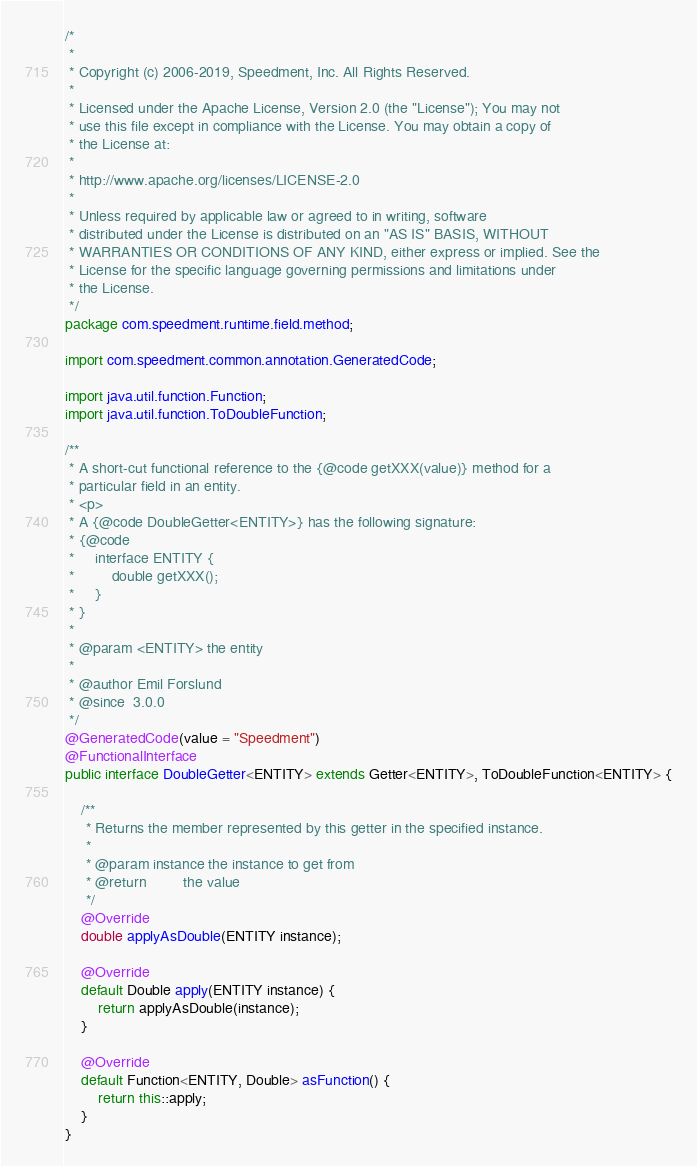<code> <loc_0><loc_0><loc_500><loc_500><_Java_>/*
 *
 * Copyright (c) 2006-2019, Speedment, Inc. All Rights Reserved.
 *
 * Licensed under the Apache License, Version 2.0 (the "License"); You may not
 * use this file except in compliance with the License. You may obtain a copy of
 * the License at:
 *
 * http://www.apache.org/licenses/LICENSE-2.0
 *
 * Unless required by applicable law or agreed to in writing, software
 * distributed under the License is distributed on an "AS IS" BASIS, WITHOUT
 * WARRANTIES OR CONDITIONS OF ANY KIND, either express or implied. See the
 * License for the specific language governing permissions and limitations under
 * the License.
 */
package com.speedment.runtime.field.method;

import com.speedment.common.annotation.GeneratedCode;

import java.util.function.Function;
import java.util.function.ToDoubleFunction;

/**
 * A short-cut functional reference to the {@code getXXX(value)} method for a
 * particular field in an entity.
 * <p>
 * A {@code DoubleGetter<ENTITY>} has the following signature:
 * {@code
 *     interface ENTITY {
 *         double getXXX();
 *     }
 * }
 * 
 * @param <ENTITY> the entity
 * 
 * @author Emil Forslund
 * @since  3.0.0
 */
@GeneratedCode(value = "Speedment")
@FunctionalInterface
public interface DoubleGetter<ENTITY> extends Getter<ENTITY>, ToDoubleFunction<ENTITY> {
    
    /**
     * Returns the member represented by this getter in the specified instance.
     * 
     * @param instance the instance to get from
     * @return         the value
     */
    @Override
    double applyAsDouble(ENTITY instance);
    
    @Override
    default Double apply(ENTITY instance) {
        return applyAsDouble(instance);
    }
    
    @Override
    default Function<ENTITY, Double> asFunction() {
        return this::apply;
    }
}</code> 